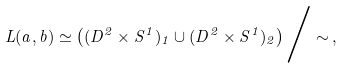Convert formula to latex. <formula><loc_0><loc_0><loc_500><loc_500>L ( a , b ) \simeq \left ( ( D ^ { 2 } \times S ^ { 1 } ) _ { 1 } \cup ( D ^ { 2 } \times S ^ { 1 } ) _ { 2 } \right ) \Big / \sim \, ,</formula> 